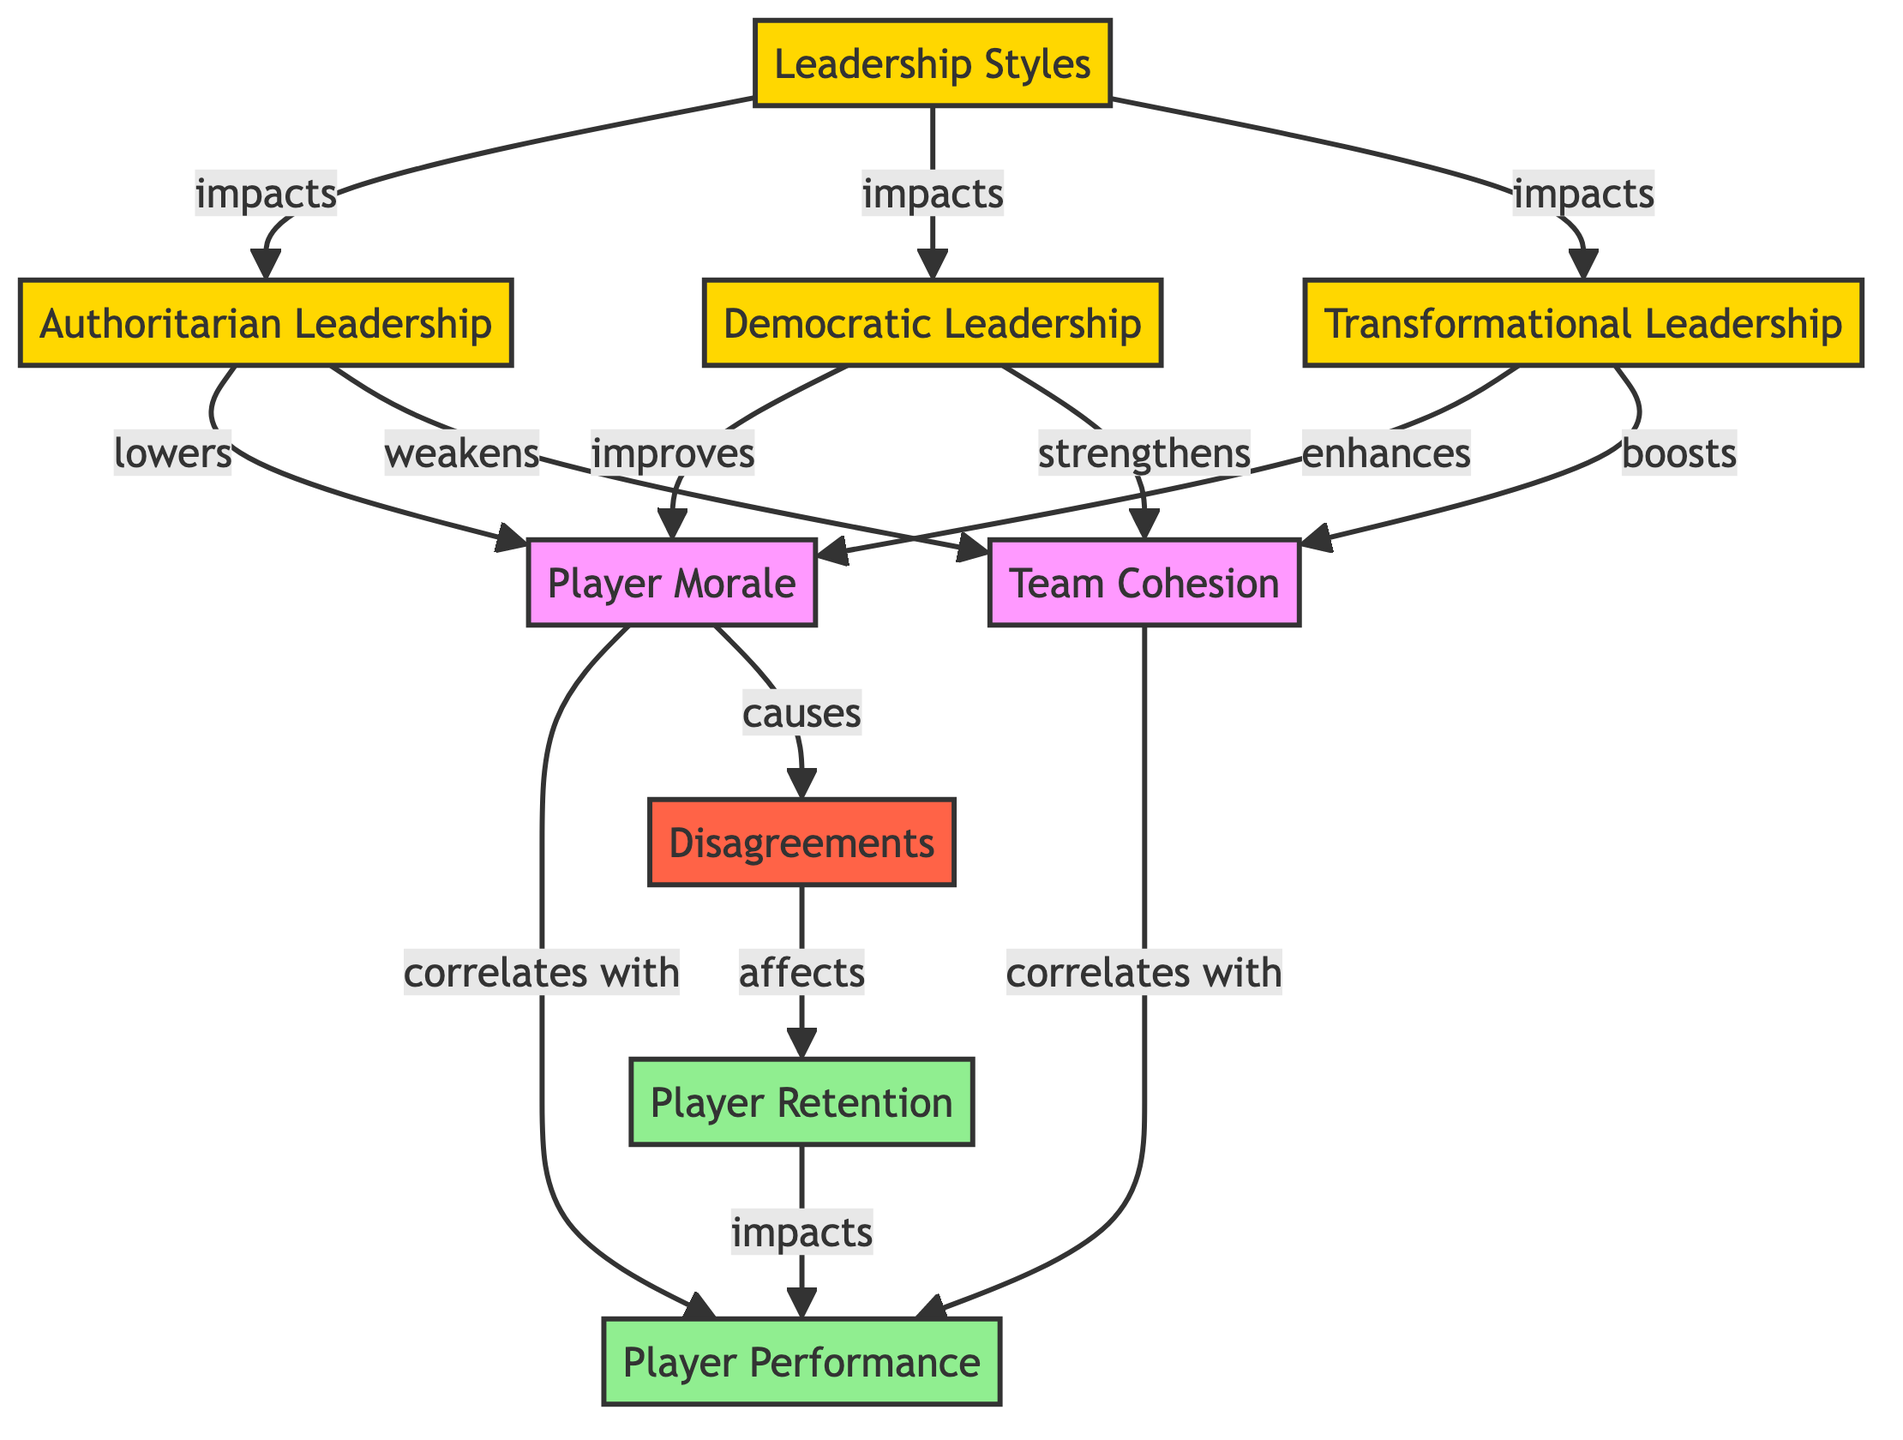what are the three types of leadership styles shown in the diagram? The diagram includes three leadership styles: Authoritarian, Democratic, and Transformational, as identified by the respective nodes connected to the Leadership Styles node.
Answer: Authoritarian, Democratic, Transformational how does Authoritarian Leadership impact Player Morale? According to the diagram, Authoritarian Leadership is indicated to 'lowers' Player Morale, which connects the two nodes directly.
Answer: lowers how many nodes are there in total? The diagram lists nine nodes, which are Leadership Styles, Authoritarian Leadership, Democratic Leadership, Transformational Leadership, Player Morale, Team Cohesion, Player Performance, Disagreements, and Player Retention.
Answer: nine what direction does Democratic Leadership affect Team Cohesion? The directed edge from Democratic Leadership to Team Cohesion shows the relationship 'strengthens,' indicating that Democratic Leadership has a positive effect on Team Cohesion.
Answer: strengthens if Player Morale causes Disagreements, how does this impact Player Retention? According to the diagram, Player Morale causes Disagreements, and Disagreements affect Player Retention, meaning that low Player Morale can indirectly negatively affect Player Retention through causing Disagreements.
Answer: affects which node correlates with Player Performance and is also related to Team Cohesion? The node that correlates with Player Performance and is related to Team Cohesion is Team Cohesion itself, as shown by the edge connections.
Answer: Team Cohesion how many edges are present in the diagram? The diagram contains twelve edges, which represent the directed relationships between the nodes.
Answer: twelve what is the effect of Transformational Leadership on Player Morale? The diagram indicates that Transformational Leadership 'enhances' Player Morale, demonstrating a positive relationship between these two nodes.
Answer: enhances what is the relationship between Player Retention and Player Performance in the context of negative Disagreements? The diagram shows that Player Retention impacts Player Performance, meaning that if Disagreements negatively affect Player Retention, it will consequently impact Player Performance negatively.
Answer: impacts 